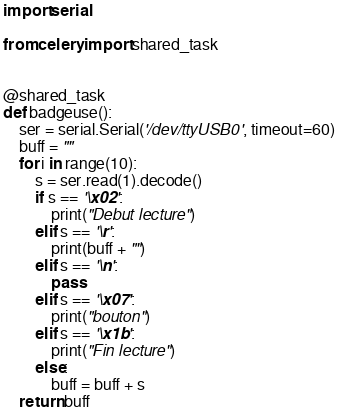<code> <loc_0><loc_0><loc_500><loc_500><_Python_>import serial

from celery import shared_task


@shared_task
def badgeuse():
    ser = serial.Serial('/dev/ttyUSB0', timeout=60)
    buff = ""
    for i in range(10):
        s = ser.read(1).decode()
        if s == '\x02':
            print("Debut lecture")
        elif s == '\r':
            print(buff + "")
        elif s == '\n':
            pass
        elif s == '\x07':
            print("bouton")
        elif s == '\x1b':
            print("Fin lecture")
        else:
            buff = buff + s
    return buff
</code> 